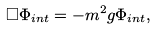<formula> <loc_0><loc_0><loc_500><loc_500>\Box \Phi _ { i n t } = - m ^ { 2 } g \Phi _ { i n t } ,</formula> 